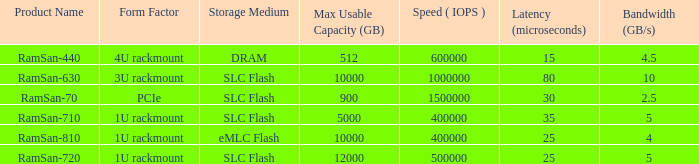What is the form deformation for the frequency range of 10? 3U rackmount. 